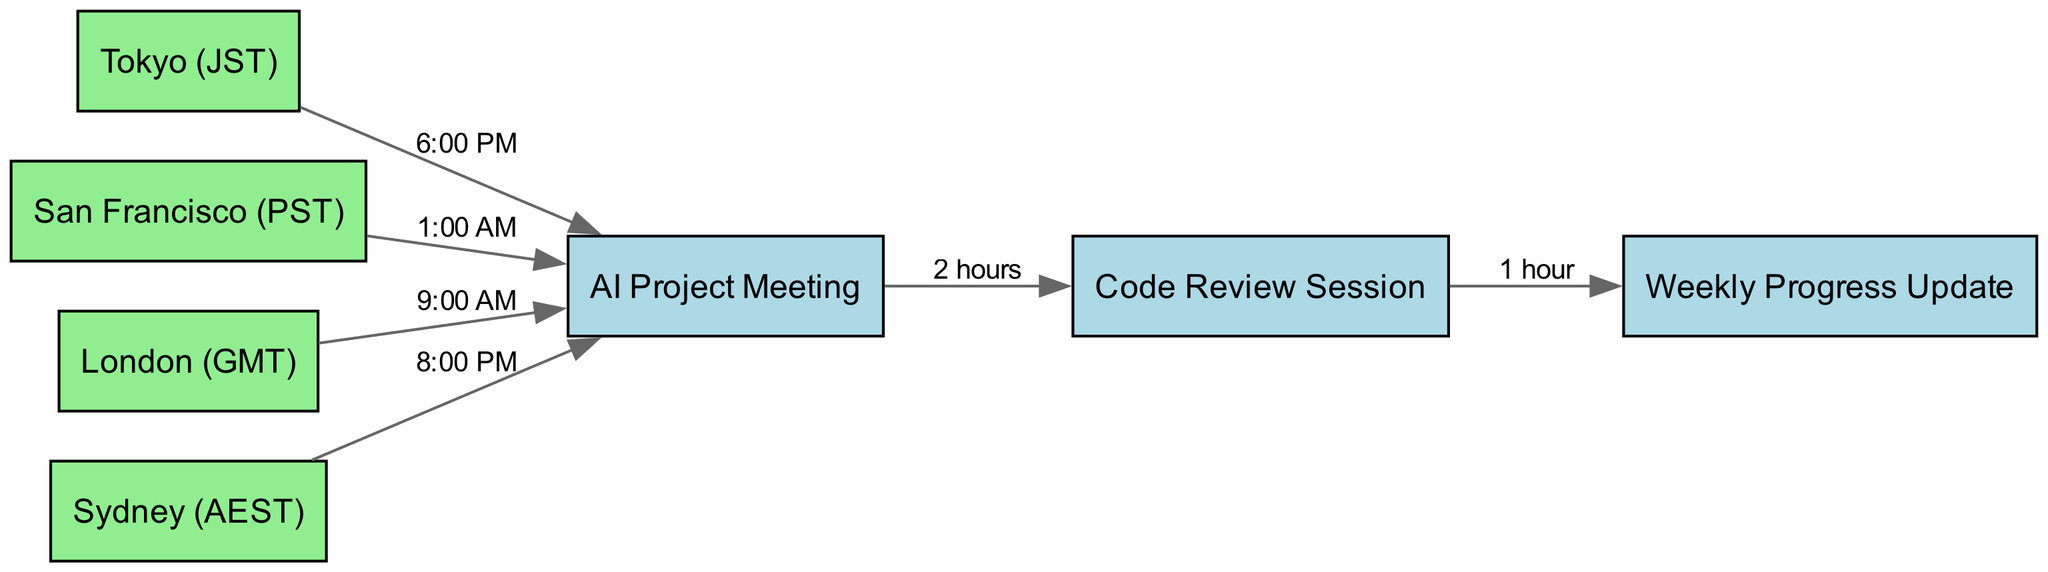What is the meeting time for London participants during the AI Project Meeting? The diagram shows that the edge connecting London (GMT) to the AI Project Meeting is labeled with "9:00 AM", indicating this as the time for London participants.
Answer: 9:00 AM How many nodes are present in the diagram? By counting each unique entry in the "nodes" list, we identify that there are seven nodes in total: Tokyo, San Francisco, London, Sydney, AI Project Meeting, Code Review Session, and Weekly Progress Update.
Answer: 7 What is the duration of the Code Review Session? The edge from the AI Project Meeting to the Code Review Session is labeled with "2 hours", indicating that the session lasts for this duration.
Answer: 2 hours Which node directly connects to the Weekly Progress Update? The diagram indicates that the Code Review Session is the direct predecessor to the Weekly Progress Update, as shown by the corresponding edge connecting them.
Answer: Code Review Session What is the meeting time for participants in Sydney during the AI Project Meeting? The edge from Sydney (AEST) to the AI Project Meeting is labeled with "8:00 PM", denoting this as the time for Sydney participants.
Answer: 8:00 PM How many edges are there in the diagram? By examining the "edges" list, we find there are six unique edges describing the connections and durations between the nodes, thus totaling six edges in the diagram.
Answer: 6 What is the meeting time for participants in San Francisco during the AI Project Meeting? The diagram shows that the connection from San Francisco (PST) to the AI Project Meeting is labeled with "1:00 AM". This designates the time for San Francisco participants.
Answer: 1:00 AM Which node precedes the AI Project Meeting in the schedule? The directed edges indicate that there are no nodes that precede the AI Project Meeting; it is the first meeting in the sequence. Thus, it does not have a predecessor node.
Answer: None 